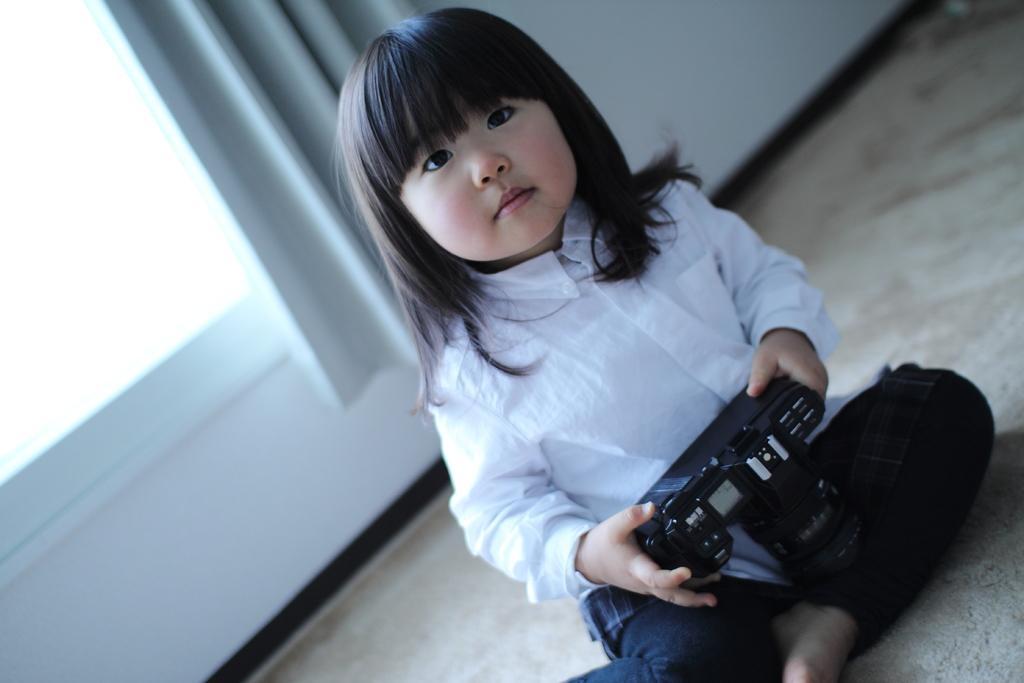Please provide a concise description of this image. In the image there is a kid sat on floor and holding a remote control, in the background there is window with curtain. 